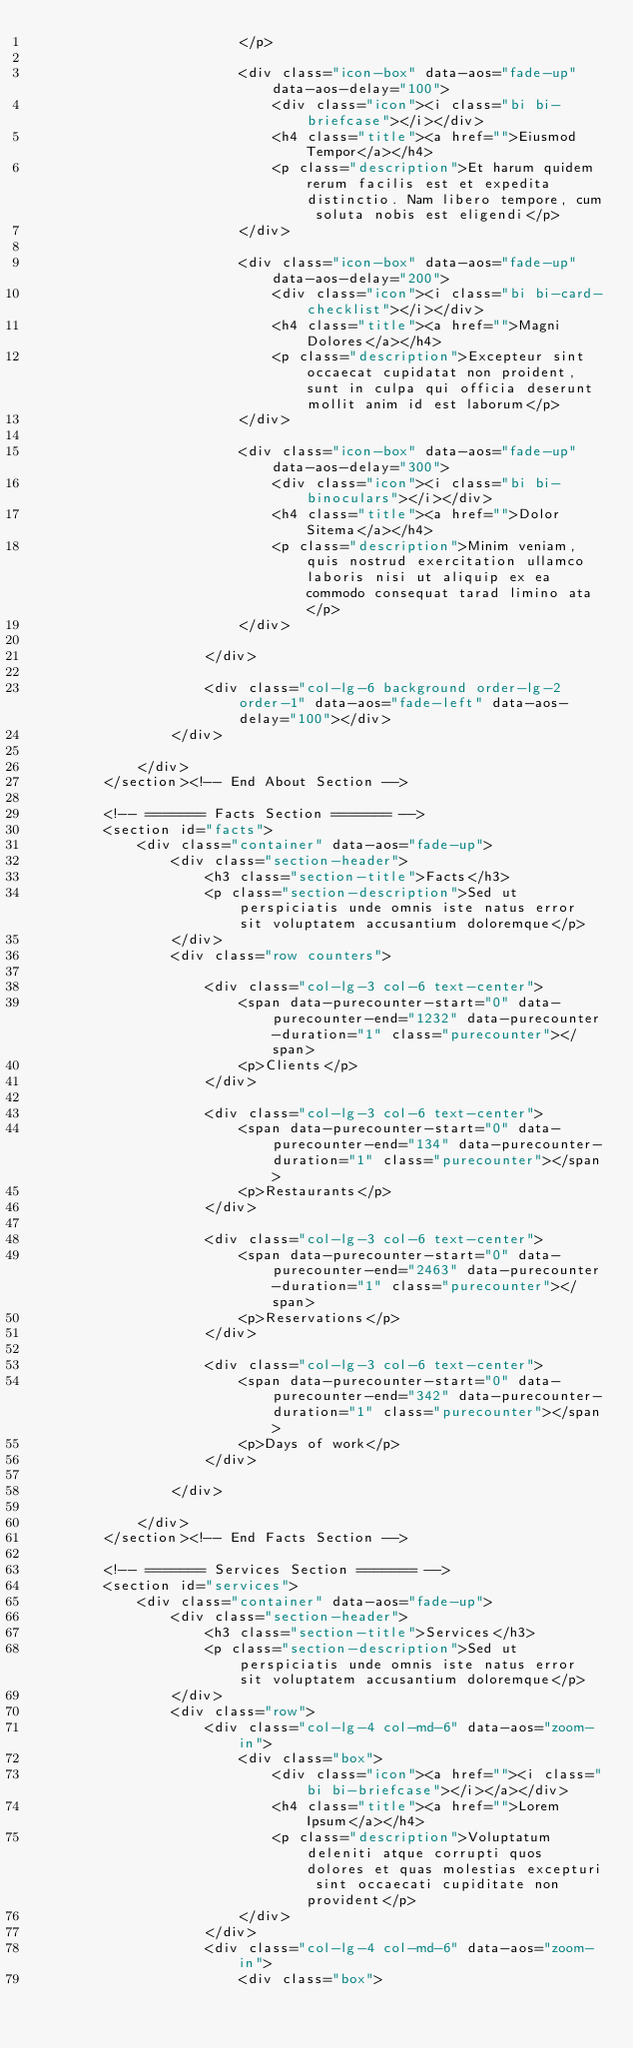Convert code to text. <code><loc_0><loc_0><loc_500><loc_500><_PHP_>                        </p>

                        <div class="icon-box" data-aos="fade-up" data-aos-delay="100">
                            <div class="icon"><i class="bi bi-briefcase"></i></div>
                            <h4 class="title"><a href="">Eiusmod Tempor</a></h4>
                            <p class="description">Et harum quidem rerum facilis est et expedita distinctio. Nam libero tempore, cum soluta nobis est eligendi</p>
                        </div>

                        <div class="icon-box" data-aos="fade-up" data-aos-delay="200">
                            <div class="icon"><i class="bi bi-card-checklist"></i></div>
                            <h4 class="title"><a href="">Magni Dolores</a></h4>
                            <p class="description">Excepteur sint occaecat cupidatat non proident, sunt in culpa qui officia deserunt mollit anim id est laborum</p>
                        </div>

                        <div class="icon-box" data-aos="fade-up" data-aos-delay="300">
                            <div class="icon"><i class="bi bi-binoculars"></i></div>
                            <h4 class="title"><a href="">Dolor Sitema</a></h4>
                            <p class="description">Minim veniam, quis nostrud exercitation ullamco laboris nisi ut aliquip ex ea commodo consequat tarad limino ata</p>
                        </div>

                    </div>

                    <div class="col-lg-6 background order-lg-2 order-1" data-aos="fade-left" data-aos-delay="100"></div>
                </div>

            </div>
        </section><!-- End About Section -->

        <!-- ======= Facts Section ======= -->
        <section id="facts">
            <div class="container" data-aos="fade-up">
                <div class="section-header">
                    <h3 class="section-title">Facts</h3>
                    <p class="section-description">Sed ut perspiciatis unde omnis iste natus error sit voluptatem accusantium doloremque</p>
                </div>
                <div class="row counters">

                    <div class="col-lg-3 col-6 text-center">
                        <span data-purecounter-start="0" data-purecounter-end="1232" data-purecounter-duration="1" class="purecounter"></span>
                        <p>Clients</p>
                    </div>

                    <div class="col-lg-3 col-6 text-center">
                        <span data-purecounter-start="0" data-purecounter-end="134" data-purecounter-duration="1" class="purecounter"></span>
                        <p>Restaurants</p>
                    </div>

                    <div class="col-lg-3 col-6 text-center">
                        <span data-purecounter-start="0" data-purecounter-end="2463" data-purecounter-duration="1" class="purecounter"></span>
                        <p>Reservations</p>
                    </div>

                    <div class="col-lg-3 col-6 text-center">
                        <span data-purecounter-start="0" data-purecounter-end="342" data-purecounter-duration="1" class="purecounter"></span>
                        <p>Days of work</p>
                    </div>

                </div>

            </div>
        </section><!-- End Facts Section -->

        <!-- ======= Services Section ======= -->
        <section id="services">
            <div class="container" data-aos="fade-up">
                <div class="section-header">
                    <h3 class="section-title">Services</h3>
                    <p class="section-description">Sed ut perspiciatis unde omnis iste natus error sit voluptatem accusantium doloremque</p>
                </div>
                <div class="row">
                    <div class="col-lg-4 col-md-6" data-aos="zoom-in">
                        <div class="box">
                            <div class="icon"><a href=""><i class="bi bi-briefcase"></i></a></div>
                            <h4 class="title"><a href="">Lorem Ipsum</a></h4>
                            <p class="description">Voluptatum deleniti atque corrupti quos dolores et quas molestias excepturi sint occaecati cupiditate non provident</p>
                        </div>
                    </div>
                    <div class="col-lg-4 col-md-6" data-aos="zoom-in">
                        <div class="box"></code> 